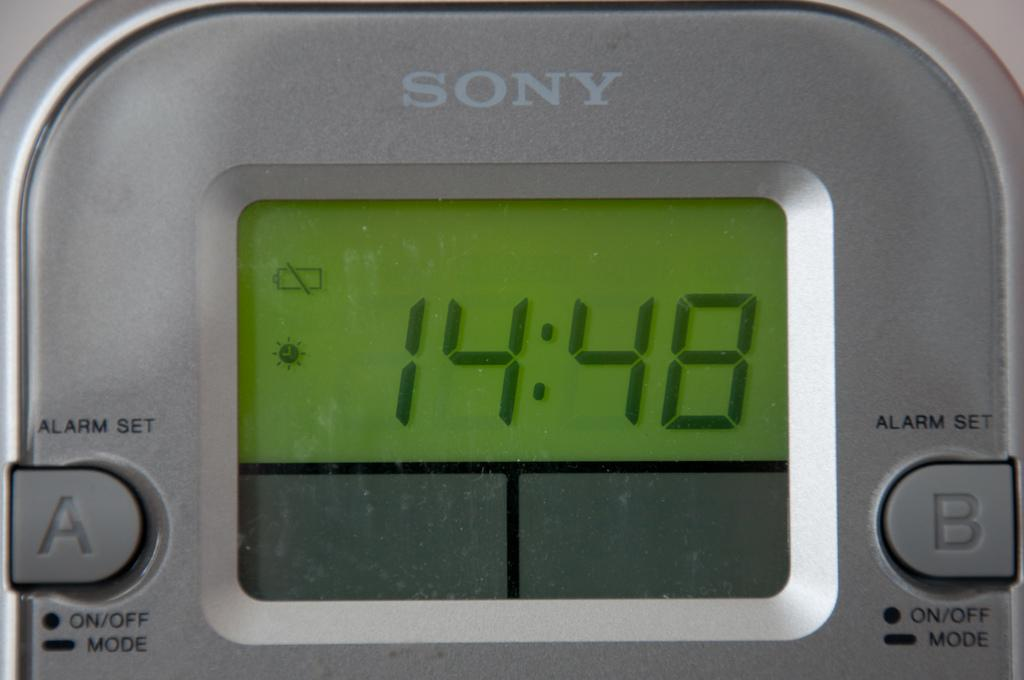<image>
Give a short and clear explanation of the subsequent image. Silver Sony alarm clock displaying 14:48 on a digital display. 